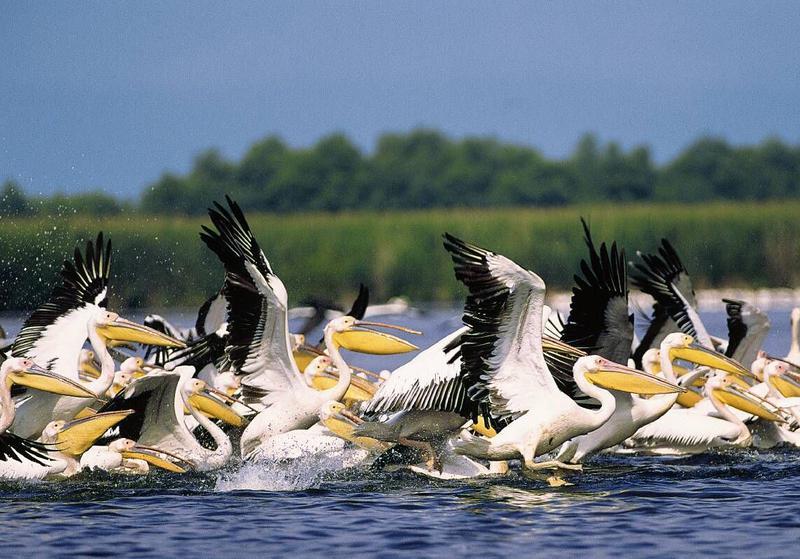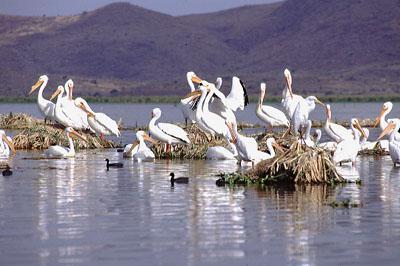The first image is the image on the left, the second image is the image on the right. For the images shown, is this caption "There are more than 5 pelicans facing right." true? Answer yes or no. Yes. The first image is the image on the left, the second image is the image on the right. For the images displayed, is the sentence "A group of spectators are observing the pelicans." factually correct? Answer yes or no. No. 